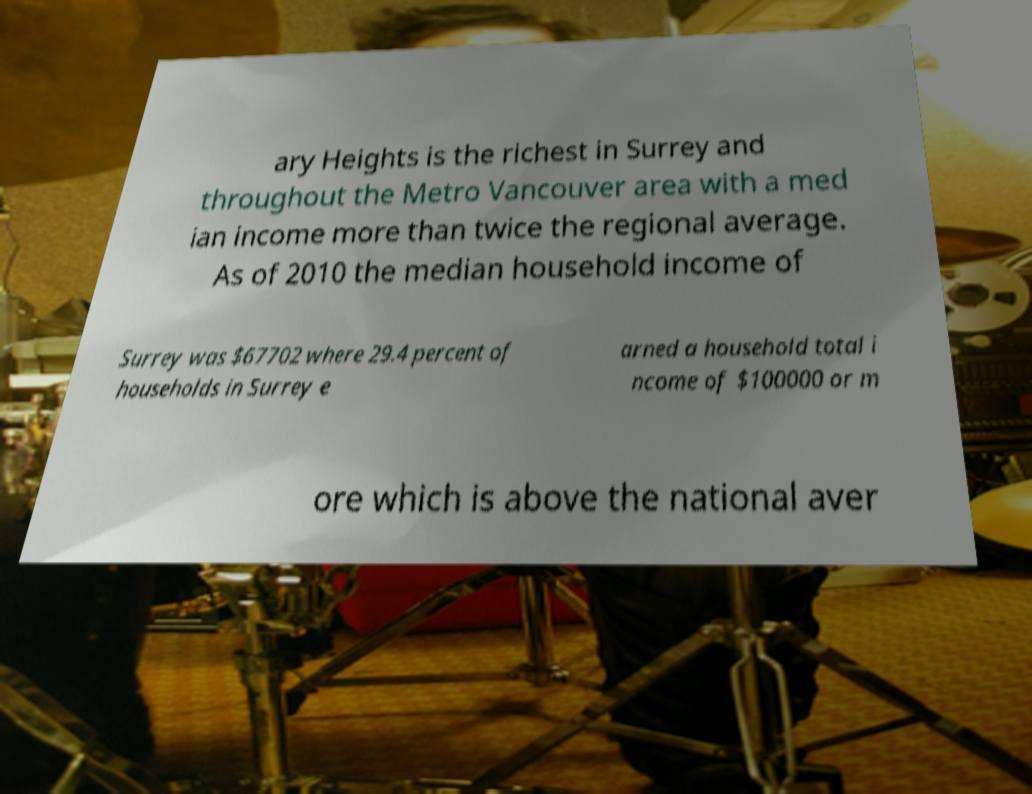Please identify and transcribe the text found in this image. ary Heights is the richest in Surrey and throughout the Metro Vancouver area with a med ian income more than twice the regional average. As of 2010 the median household income of Surrey was $67702 where 29.4 percent of households in Surrey e arned a household total i ncome of $100000 or m ore which is above the national aver 